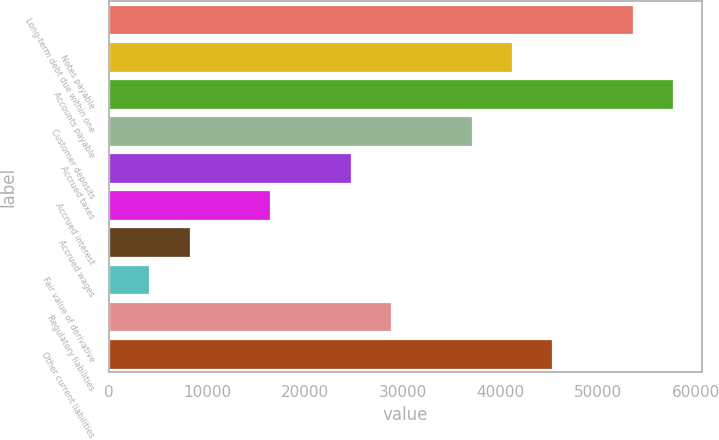Convert chart. <chart><loc_0><loc_0><loc_500><loc_500><bar_chart><fcel>Long-term debt due within one<fcel>Notes payable<fcel>Accounts payable<fcel>Customer deposits<fcel>Accrued taxes<fcel>Accrued interest<fcel>Accrued wages<fcel>Fair value of derivative<fcel>Regulatory liabilities<fcel>Other current liabilities<nl><fcel>53571.1<fcel>41209<fcel>57691.8<fcel>37088.3<fcel>24726.2<fcel>16484.8<fcel>8243.4<fcel>4122.7<fcel>28846.9<fcel>45329.7<nl></chart> 